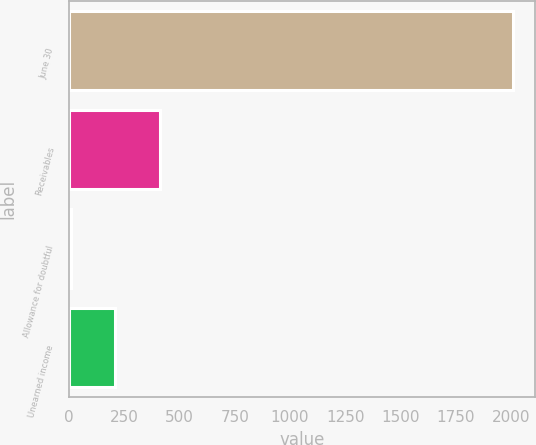Convert chart to OTSL. <chart><loc_0><loc_0><loc_500><loc_500><bar_chart><fcel>June 30<fcel>Receivables<fcel>Allowance for doubtful<fcel>Unearned income<nl><fcel>2009<fcel>409.72<fcel>9.9<fcel>209.81<nl></chart> 